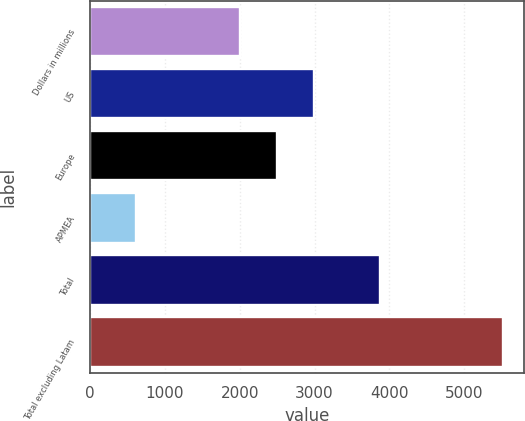Convert chart. <chart><loc_0><loc_0><loc_500><loc_500><bar_chart><fcel>Dollars in millions<fcel>US<fcel>Europe<fcel>APMEA<fcel>Total<fcel>Total excluding Latam<nl><fcel>2007<fcel>2987.8<fcel>2497.4<fcel>616<fcel>3879<fcel>5520<nl></chart> 